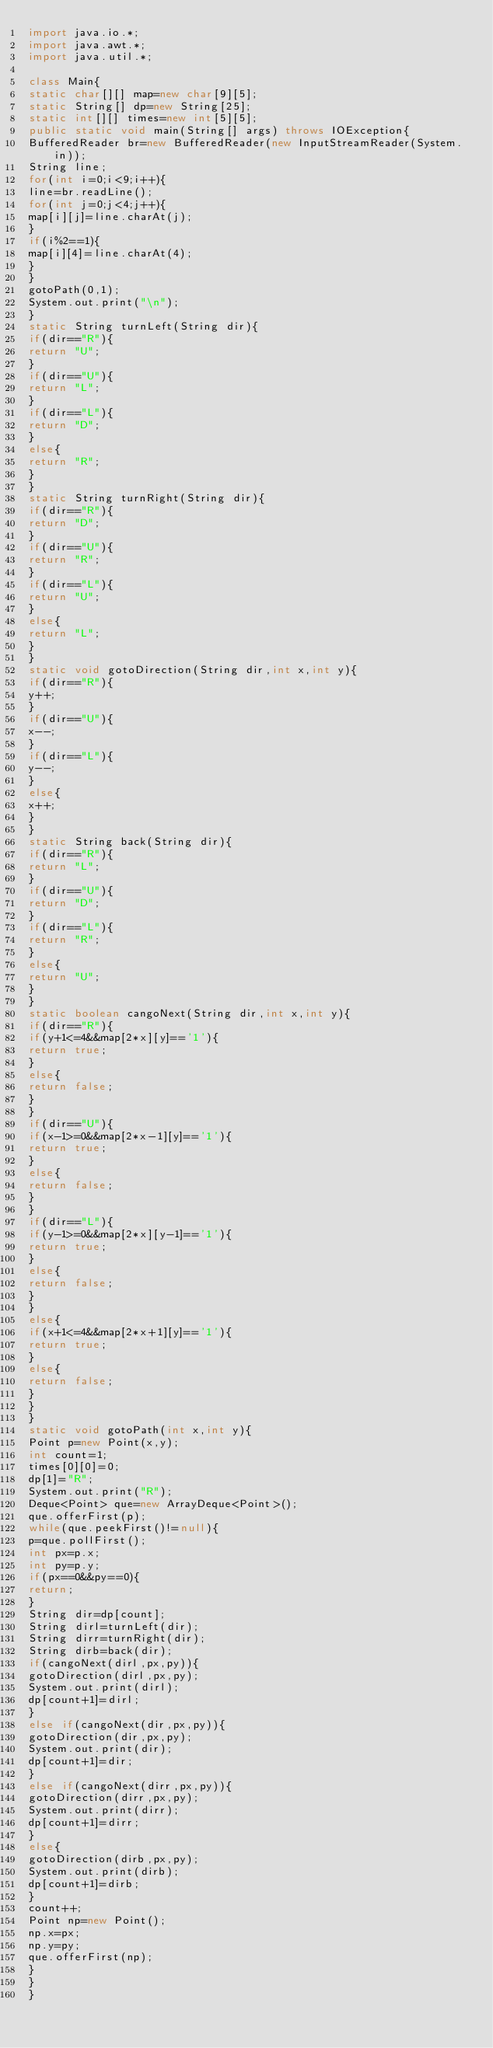Convert code to text. <code><loc_0><loc_0><loc_500><loc_500><_Java_>import java.io.*;
import java.awt.*;
import java.util.*;
 
class Main{
static char[][] map=new char[9][5];
static String[] dp=new String[25];
static int[][] times=new int[5][5];
public static void main(String[] args) throws IOException{
BufferedReader br=new BufferedReader(new InputStreamReader(System.in));
String line;
for(int i=0;i<9;i++){
line=br.readLine();
for(int j=0;j<4;j++){
map[i][j]=line.charAt(j);
}
if(i%2==1){
map[i][4]=line.charAt(4);
}
}
gotoPath(0,1);
System.out.print("\n");
}
static String turnLeft(String dir){
if(dir=="R"){
return "U";
}
if(dir=="U"){
return "L";
}
if(dir=="L"){
return "D";
}
else{
return "R";
}
}
static String turnRight(String dir){
if(dir=="R"){
return "D";
}
if(dir=="U"){
return "R";
}
if(dir=="L"){
return "U";
}
else{
return "L";
}
}
static void gotoDirection(String dir,int x,int y){
if(dir=="R"){
y++;
}
if(dir=="U"){
x--;
}
if(dir=="L"){
y--;
}
else{
x++;
}
}
static String back(String dir){
if(dir=="R"){
return "L";
}
if(dir=="U"){
return "D";
}
if(dir=="L"){
return "R";
}
else{
return "U";
}
}
static boolean cangoNext(String dir,int x,int y){
if(dir=="R"){
if(y+1<=4&&map[2*x][y]=='1'){
return true;
}
else{
return false;
}
}
if(dir=="U"){
if(x-1>=0&&map[2*x-1][y]=='1'){
return true;
}
else{
return false;
}
}
if(dir=="L"){
if(y-1>=0&&map[2*x][y-1]=='1'){
return true;
}
else{
return false;
}
}
else{
if(x+1<=4&&map[2*x+1][y]=='1'){
return true;
}
else{
return false;
}
}
}
static void gotoPath(int x,int y){
Point p=new Point(x,y);
int count=1;
times[0][0]=0;
dp[1]="R";
System.out.print("R");
Deque<Point> que=new ArrayDeque<Point>();
que.offerFirst(p);
while(que.peekFirst()!=null){
p=que.pollFirst();
int px=p.x;
int py=p.y;
if(px==0&&py==0){
return;
}
String dir=dp[count];
String dirl=turnLeft(dir);
String dirr=turnRight(dir);
String dirb=back(dir);
if(cangoNext(dirl,px,py)){
gotoDirection(dirl,px,py);
System.out.print(dirl);
dp[count+1]=dirl;
}
else if(cangoNext(dir,px,py)){
gotoDirection(dir,px,py);
System.out.print(dir);
dp[count+1]=dir;
}
else if(cangoNext(dirr,px,py)){
gotoDirection(dirr,px,py);
System.out.print(dirr);
dp[count+1]=dirr;
}
else{
gotoDirection(dirb,px,py);
System.out.print(dirb);
dp[count+1]=dirb;
}
count++;
Point np=new Point();
np.x=px;
np.y=py;
que.offerFirst(np);
}
}
}</code> 